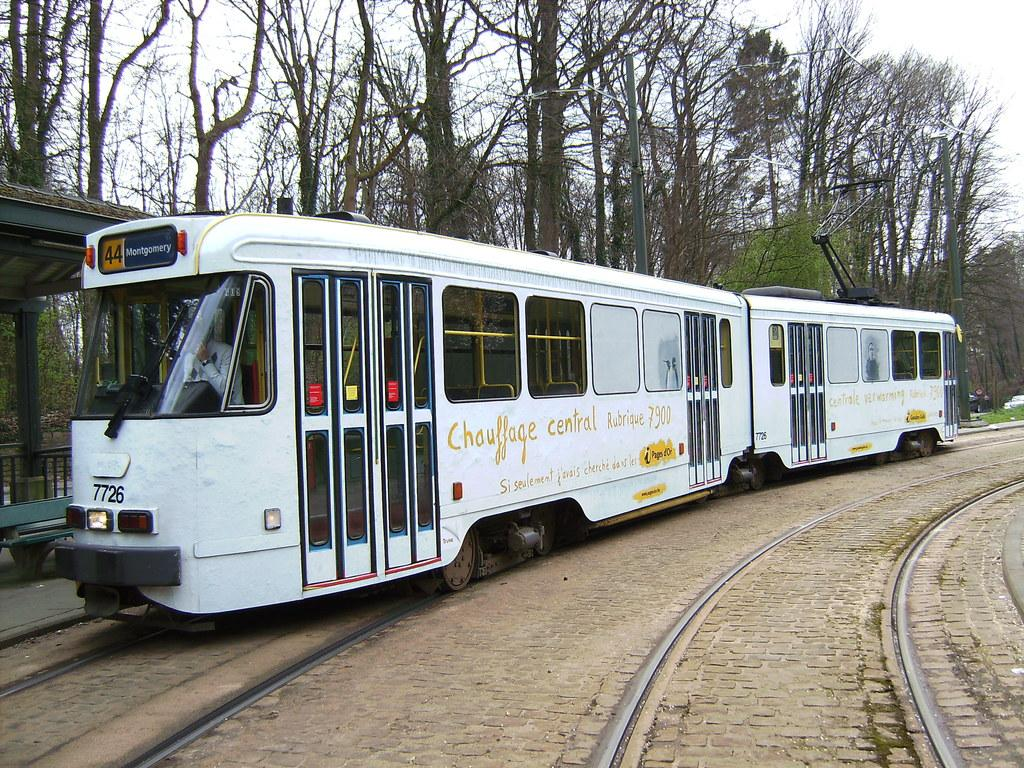What is the main subject of the image? The main subject of the image is a train. What can be seen on the train? There is text on the train. What is located on the right side of the image? There is a railway track on the right side of the image. What is visible in the background of the image? Trees and the sky are visible in the background of the image. Can you tell me who won the argument between the train and the trees in the image? There is no argument present in the image; it features a train, railway track, trees, and the sky. What color is the ear of the person sitting in the train in the image? There is no person or ear visible in the image; it only shows a train, railway track, trees, and the sky. 